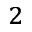Convert formula to latex. <formula><loc_0><loc_0><loc_500><loc_500>^ { 2 }</formula> 